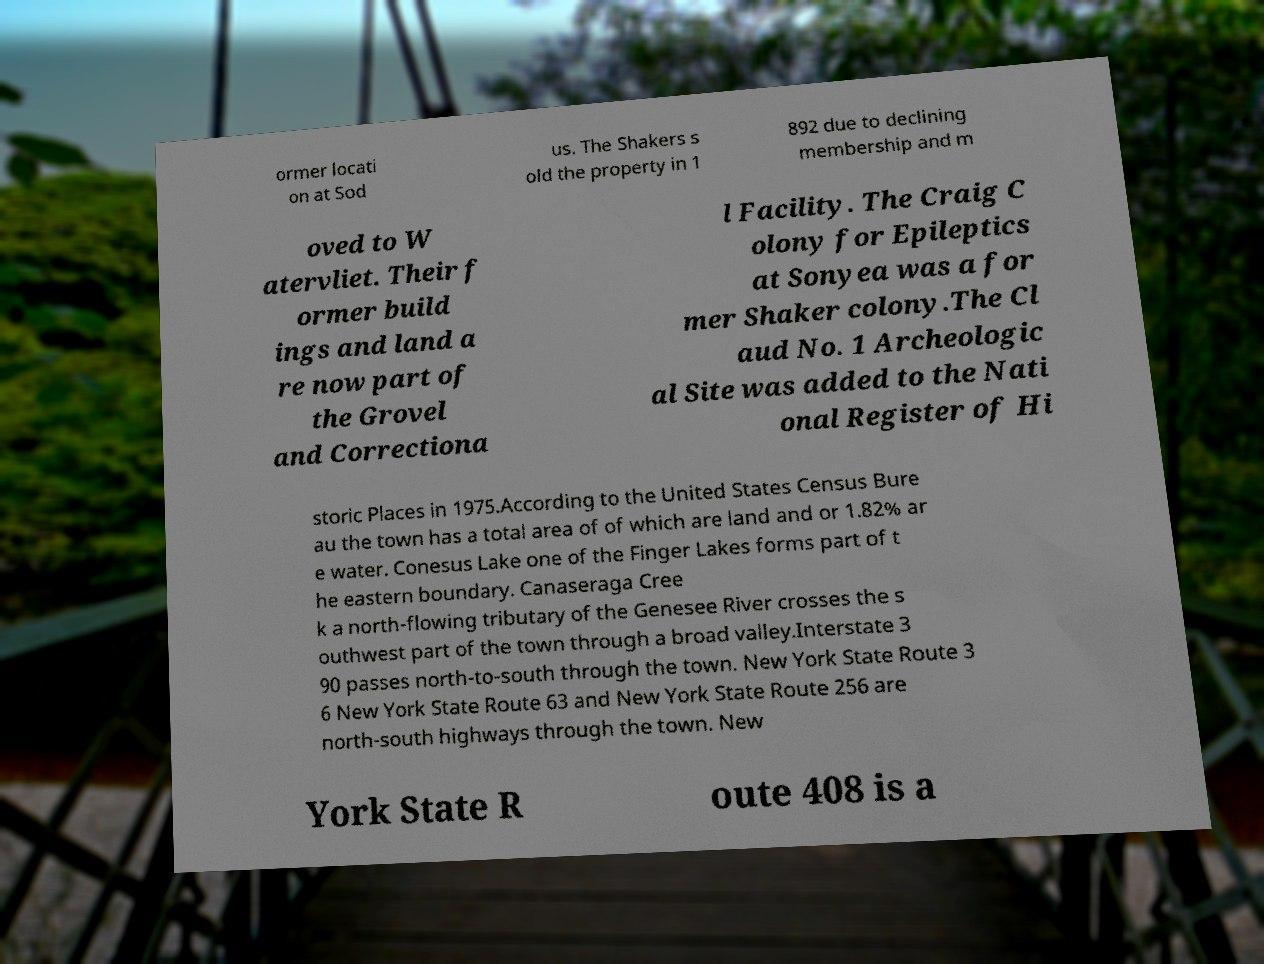Can you read and provide the text displayed in the image?This photo seems to have some interesting text. Can you extract and type it out for me? ormer locati on at Sod us. The Shakers s old the property in 1 892 due to declining membership and m oved to W atervliet. Their f ormer build ings and land a re now part of the Grovel and Correctiona l Facility. The Craig C olony for Epileptics at Sonyea was a for mer Shaker colony.The Cl aud No. 1 Archeologic al Site was added to the Nati onal Register of Hi storic Places in 1975.According to the United States Census Bure au the town has a total area of of which are land and or 1.82% ar e water. Conesus Lake one of the Finger Lakes forms part of t he eastern boundary. Canaseraga Cree k a north-flowing tributary of the Genesee River crosses the s outhwest part of the town through a broad valley.Interstate 3 90 passes north-to-south through the town. New York State Route 3 6 New York State Route 63 and New York State Route 256 are north-south highways through the town. New York State R oute 408 is a 